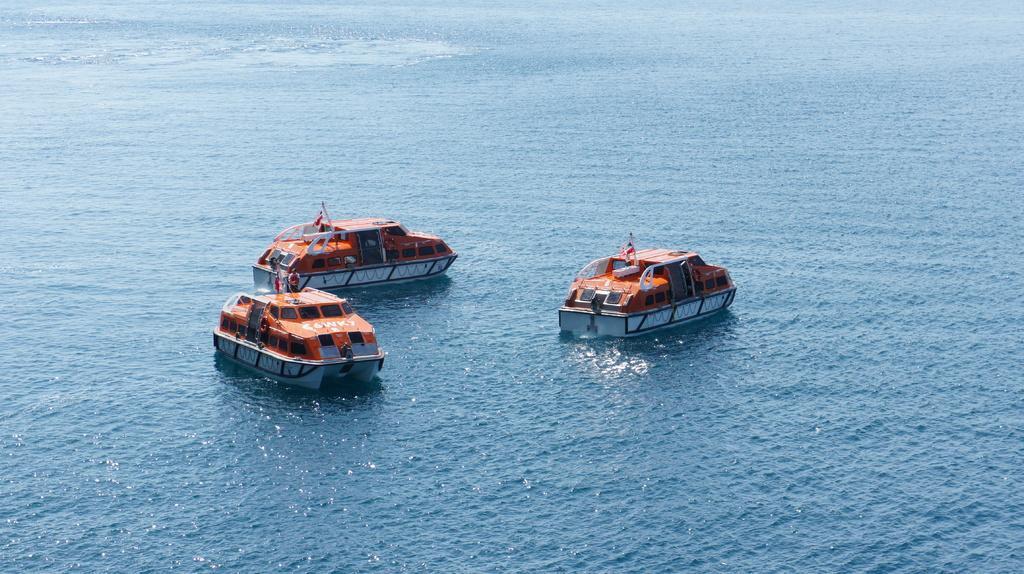Can you describe this image briefly? In the center of the image there are ships on the water. 